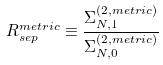<formula> <loc_0><loc_0><loc_500><loc_500>R ^ { m e t r i c } _ { s e p } \equiv \frac { \Sigma ^ { ( 2 , m e t r i c ) } _ { N , 1 } } { \Sigma ^ { ( 2 , m e t r i c ) } _ { N , 0 } }</formula> 